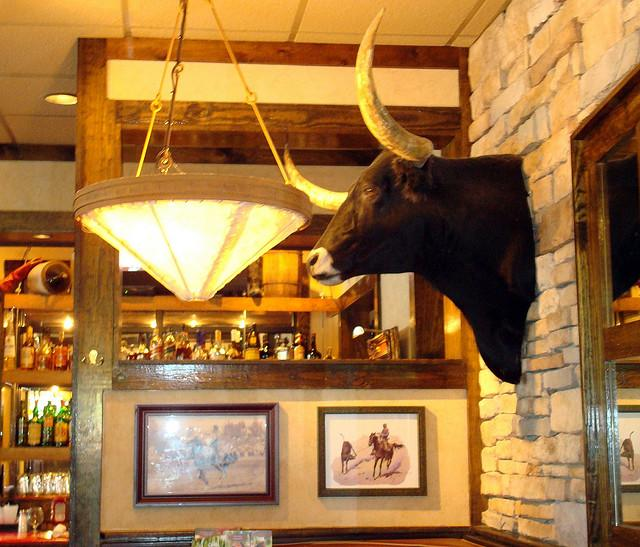What type of facility is displaying the animal head? bar 